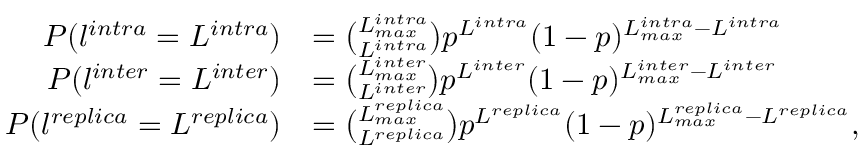Convert formula to latex. <formula><loc_0><loc_0><loc_500><loc_500>\begin{array} { r l } { P ( l ^ { i n t r a } = L ^ { i n t r a } ) } & { = \binom { L _ { \max } ^ { i n t r a } } { L ^ { i n t r a } } p ^ { L ^ { i n t r a } } ( 1 - p ) ^ { L _ { \max } ^ { i n t r a } - L ^ { i n t r a } } } \\ { P ( l ^ { i n t e r } = L ^ { i n t e r } ) } & { = \binom { L _ { \max } ^ { i n t e r } } { L ^ { i n t e r } } p ^ { L ^ { i n t e r } } ( 1 - p ) ^ { L _ { \max } ^ { i n t e r } - L ^ { i n t e r } } } \\ { P ( l ^ { r e p l i c a } = L ^ { r e p l i c a } ) } & { = \binom { L _ { \max } ^ { r e p l i c a } } { L ^ { r e p l i c a } } p ^ { L ^ { r e p l i c a } } ( 1 - p ) ^ { L _ { \max } ^ { r e p l i c a } - L ^ { r e p l i c a } } , } \end{array}</formula> 